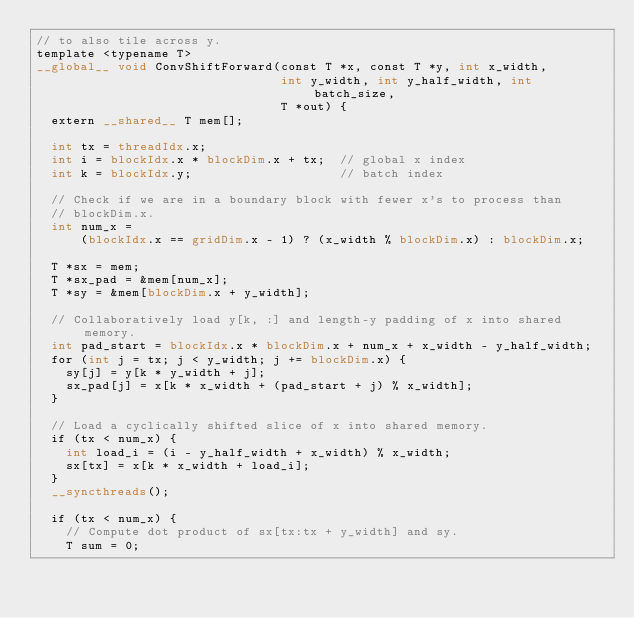Convert code to text. <code><loc_0><loc_0><loc_500><loc_500><_Cuda_>// to also tile across y.
template <typename T>
__global__ void ConvShiftForward(const T *x, const T *y, int x_width,
                                 int y_width, int y_half_width, int batch_size,
                                 T *out) {
  extern __shared__ T mem[];

  int tx = threadIdx.x;
  int i = blockIdx.x * blockDim.x + tx;  // global x index
  int k = blockIdx.y;                    // batch index

  // Check if we are in a boundary block with fewer x's to process than
  // blockDim.x.
  int num_x =
      (blockIdx.x == gridDim.x - 1) ? (x_width % blockDim.x) : blockDim.x;

  T *sx = mem;
  T *sx_pad = &mem[num_x];
  T *sy = &mem[blockDim.x + y_width];

  // Collaboratively load y[k, :] and length-y padding of x into shared memory.
  int pad_start = blockIdx.x * blockDim.x + num_x + x_width - y_half_width;
  for (int j = tx; j < y_width; j += blockDim.x) {
    sy[j] = y[k * y_width + j];
    sx_pad[j] = x[k * x_width + (pad_start + j) % x_width];
  }

  // Load a cyclically shifted slice of x into shared memory.
  if (tx < num_x) {
    int load_i = (i - y_half_width + x_width) % x_width;
    sx[tx] = x[k * x_width + load_i];
  }
  __syncthreads();

  if (tx < num_x) {
    // Compute dot product of sx[tx:tx + y_width] and sy.
    T sum = 0;</code> 